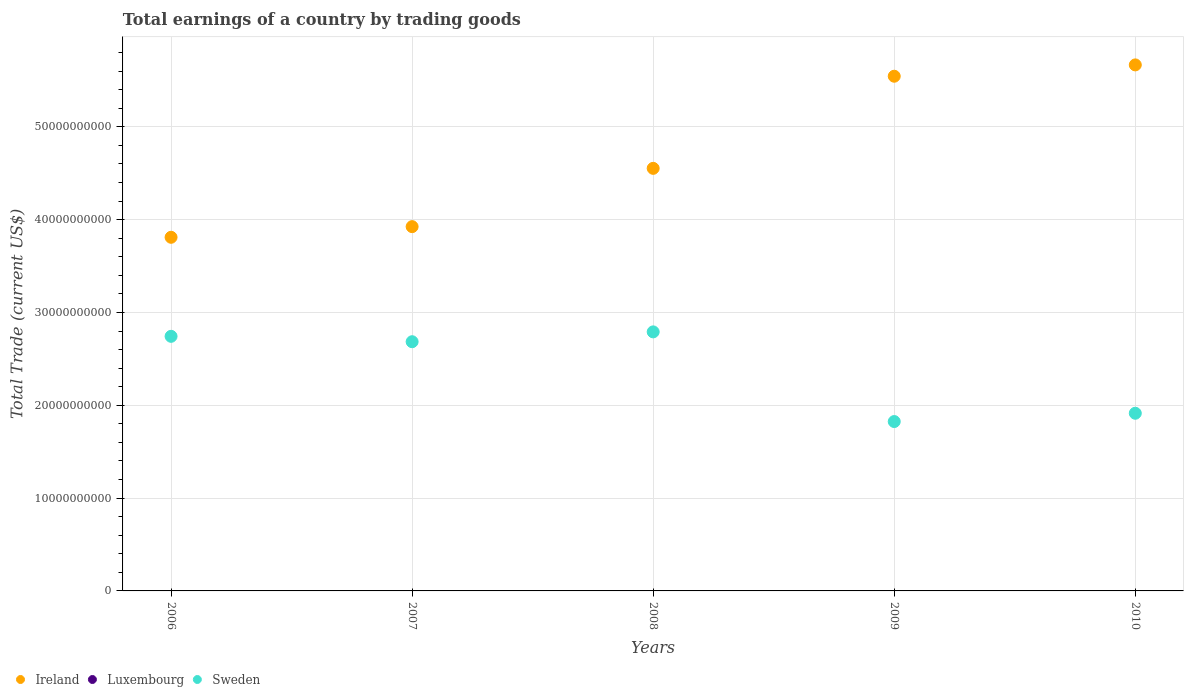What is the total earnings in Sweden in 2006?
Keep it short and to the point. 2.74e+1. Across all years, what is the maximum total earnings in Sweden?
Offer a terse response. 2.79e+1. Across all years, what is the minimum total earnings in Sweden?
Ensure brevity in your answer.  1.82e+1. In which year was the total earnings in Ireland maximum?
Your response must be concise. 2010. What is the total total earnings in Luxembourg in the graph?
Your answer should be compact. 0. What is the difference between the total earnings in Sweden in 2009 and that in 2010?
Provide a short and direct response. -8.94e+08. What is the difference between the total earnings in Luxembourg in 2008 and the total earnings in Ireland in 2010?
Give a very brief answer. -5.67e+1. What is the average total earnings in Luxembourg per year?
Your response must be concise. 0. In the year 2010, what is the difference between the total earnings in Ireland and total earnings in Sweden?
Ensure brevity in your answer.  3.75e+1. What is the ratio of the total earnings in Ireland in 2006 to that in 2010?
Make the answer very short. 0.67. Is the difference between the total earnings in Ireland in 2008 and 2009 greater than the difference between the total earnings in Sweden in 2008 and 2009?
Offer a very short reply. No. What is the difference between the highest and the second highest total earnings in Sweden?
Keep it short and to the point. 4.79e+08. What is the difference between the highest and the lowest total earnings in Ireland?
Provide a short and direct response. 1.86e+1. In how many years, is the total earnings in Luxembourg greater than the average total earnings in Luxembourg taken over all years?
Keep it short and to the point. 0. Is the sum of the total earnings in Ireland in 2006 and 2010 greater than the maximum total earnings in Luxembourg across all years?
Your response must be concise. Yes. Is it the case that in every year, the sum of the total earnings in Ireland and total earnings in Luxembourg  is greater than the total earnings in Sweden?
Provide a succinct answer. Yes. Does the total earnings in Luxembourg monotonically increase over the years?
Provide a short and direct response. No. Is the total earnings in Sweden strictly greater than the total earnings in Luxembourg over the years?
Offer a terse response. Yes. How many years are there in the graph?
Offer a terse response. 5. What is the difference between two consecutive major ticks on the Y-axis?
Keep it short and to the point. 1.00e+1. Are the values on the major ticks of Y-axis written in scientific E-notation?
Keep it short and to the point. No. Does the graph contain any zero values?
Keep it short and to the point. Yes. How many legend labels are there?
Provide a succinct answer. 3. How are the legend labels stacked?
Provide a short and direct response. Horizontal. What is the title of the graph?
Keep it short and to the point. Total earnings of a country by trading goods. Does "United Arab Emirates" appear as one of the legend labels in the graph?
Your answer should be very brief. No. What is the label or title of the Y-axis?
Make the answer very short. Total Trade (current US$). What is the Total Trade (current US$) of Ireland in 2006?
Your response must be concise. 3.81e+1. What is the Total Trade (current US$) of Sweden in 2006?
Your answer should be compact. 2.74e+1. What is the Total Trade (current US$) of Ireland in 2007?
Your response must be concise. 3.92e+1. What is the Total Trade (current US$) in Sweden in 2007?
Provide a short and direct response. 2.68e+1. What is the Total Trade (current US$) in Ireland in 2008?
Ensure brevity in your answer.  4.55e+1. What is the Total Trade (current US$) of Luxembourg in 2008?
Your answer should be very brief. 0. What is the Total Trade (current US$) in Sweden in 2008?
Your response must be concise. 2.79e+1. What is the Total Trade (current US$) in Ireland in 2009?
Offer a very short reply. 5.54e+1. What is the Total Trade (current US$) of Sweden in 2009?
Offer a very short reply. 1.82e+1. What is the Total Trade (current US$) of Ireland in 2010?
Provide a succinct answer. 5.67e+1. What is the Total Trade (current US$) of Sweden in 2010?
Provide a short and direct response. 1.91e+1. Across all years, what is the maximum Total Trade (current US$) in Ireland?
Give a very brief answer. 5.67e+1. Across all years, what is the maximum Total Trade (current US$) in Sweden?
Provide a succinct answer. 2.79e+1. Across all years, what is the minimum Total Trade (current US$) in Ireland?
Provide a short and direct response. 3.81e+1. Across all years, what is the minimum Total Trade (current US$) in Sweden?
Your answer should be very brief. 1.82e+1. What is the total Total Trade (current US$) in Ireland in the graph?
Make the answer very short. 2.35e+11. What is the total Total Trade (current US$) in Luxembourg in the graph?
Provide a short and direct response. 0. What is the total Total Trade (current US$) of Sweden in the graph?
Ensure brevity in your answer.  1.20e+11. What is the difference between the Total Trade (current US$) in Ireland in 2006 and that in 2007?
Give a very brief answer. -1.15e+09. What is the difference between the Total Trade (current US$) of Sweden in 2006 and that in 2007?
Keep it short and to the point. 5.80e+08. What is the difference between the Total Trade (current US$) in Ireland in 2006 and that in 2008?
Provide a short and direct response. -7.43e+09. What is the difference between the Total Trade (current US$) in Sweden in 2006 and that in 2008?
Provide a short and direct response. -4.79e+08. What is the difference between the Total Trade (current US$) of Ireland in 2006 and that in 2009?
Provide a succinct answer. -1.74e+1. What is the difference between the Total Trade (current US$) in Sweden in 2006 and that in 2009?
Give a very brief answer. 9.18e+09. What is the difference between the Total Trade (current US$) in Ireland in 2006 and that in 2010?
Provide a succinct answer. -1.86e+1. What is the difference between the Total Trade (current US$) of Sweden in 2006 and that in 2010?
Your response must be concise. 8.29e+09. What is the difference between the Total Trade (current US$) in Ireland in 2007 and that in 2008?
Provide a short and direct response. -6.28e+09. What is the difference between the Total Trade (current US$) of Sweden in 2007 and that in 2008?
Keep it short and to the point. -1.06e+09. What is the difference between the Total Trade (current US$) of Ireland in 2007 and that in 2009?
Your answer should be very brief. -1.62e+1. What is the difference between the Total Trade (current US$) in Sweden in 2007 and that in 2009?
Your answer should be very brief. 8.60e+09. What is the difference between the Total Trade (current US$) of Ireland in 2007 and that in 2010?
Your answer should be very brief. -1.74e+1. What is the difference between the Total Trade (current US$) in Sweden in 2007 and that in 2010?
Keep it short and to the point. 7.71e+09. What is the difference between the Total Trade (current US$) in Ireland in 2008 and that in 2009?
Your response must be concise. -9.92e+09. What is the difference between the Total Trade (current US$) in Sweden in 2008 and that in 2009?
Make the answer very short. 9.66e+09. What is the difference between the Total Trade (current US$) in Ireland in 2008 and that in 2010?
Ensure brevity in your answer.  -1.11e+1. What is the difference between the Total Trade (current US$) of Sweden in 2008 and that in 2010?
Make the answer very short. 8.77e+09. What is the difference between the Total Trade (current US$) of Ireland in 2009 and that in 2010?
Your answer should be very brief. -1.22e+09. What is the difference between the Total Trade (current US$) of Sweden in 2009 and that in 2010?
Your answer should be very brief. -8.94e+08. What is the difference between the Total Trade (current US$) in Ireland in 2006 and the Total Trade (current US$) in Sweden in 2007?
Keep it short and to the point. 1.13e+1. What is the difference between the Total Trade (current US$) of Ireland in 2006 and the Total Trade (current US$) of Sweden in 2008?
Ensure brevity in your answer.  1.02e+1. What is the difference between the Total Trade (current US$) of Ireland in 2006 and the Total Trade (current US$) of Sweden in 2009?
Ensure brevity in your answer.  1.99e+1. What is the difference between the Total Trade (current US$) of Ireland in 2006 and the Total Trade (current US$) of Sweden in 2010?
Ensure brevity in your answer.  1.90e+1. What is the difference between the Total Trade (current US$) in Ireland in 2007 and the Total Trade (current US$) in Sweden in 2008?
Your answer should be compact. 1.13e+1. What is the difference between the Total Trade (current US$) of Ireland in 2007 and the Total Trade (current US$) of Sweden in 2009?
Give a very brief answer. 2.10e+1. What is the difference between the Total Trade (current US$) in Ireland in 2007 and the Total Trade (current US$) in Sweden in 2010?
Ensure brevity in your answer.  2.01e+1. What is the difference between the Total Trade (current US$) in Ireland in 2008 and the Total Trade (current US$) in Sweden in 2009?
Your answer should be compact. 2.73e+1. What is the difference between the Total Trade (current US$) of Ireland in 2008 and the Total Trade (current US$) of Sweden in 2010?
Offer a very short reply. 2.64e+1. What is the difference between the Total Trade (current US$) of Ireland in 2009 and the Total Trade (current US$) of Sweden in 2010?
Ensure brevity in your answer.  3.63e+1. What is the average Total Trade (current US$) of Ireland per year?
Your response must be concise. 4.70e+1. What is the average Total Trade (current US$) in Sweden per year?
Provide a succinct answer. 2.39e+1. In the year 2006, what is the difference between the Total Trade (current US$) in Ireland and Total Trade (current US$) in Sweden?
Ensure brevity in your answer.  1.07e+1. In the year 2007, what is the difference between the Total Trade (current US$) in Ireland and Total Trade (current US$) in Sweden?
Make the answer very short. 1.24e+1. In the year 2008, what is the difference between the Total Trade (current US$) of Ireland and Total Trade (current US$) of Sweden?
Provide a short and direct response. 1.76e+1. In the year 2009, what is the difference between the Total Trade (current US$) of Ireland and Total Trade (current US$) of Sweden?
Your answer should be compact. 3.72e+1. In the year 2010, what is the difference between the Total Trade (current US$) in Ireland and Total Trade (current US$) in Sweden?
Offer a very short reply. 3.75e+1. What is the ratio of the Total Trade (current US$) in Ireland in 2006 to that in 2007?
Provide a short and direct response. 0.97. What is the ratio of the Total Trade (current US$) of Sweden in 2006 to that in 2007?
Make the answer very short. 1.02. What is the ratio of the Total Trade (current US$) of Ireland in 2006 to that in 2008?
Give a very brief answer. 0.84. What is the ratio of the Total Trade (current US$) of Sweden in 2006 to that in 2008?
Provide a succinct answer. 0.98. What is the ratio of the Total Trade (current US$) of Ireland in 2006 to that in 2009?
Your response must be concise. 0.69. What is the ratio of the Total Trade (current US$) in Sweden in 2006 to that in 2009?
Provide a short and direct response. 1.5. What is the ratio of the Total Trade (current US$) of Ireland in 2006 to that in 2010?
Your answer should be compact. 0.67. What is the ratio of the Total Trade (current US$) in Sweden in 2006 to that in 2010?
Offer a terse response. 1.43. What is the ratio of the Total Trade (current US$) of Ireland in 2007 to that in 2008?
Offer a very short reply. 0.86. What is the ratio of the Total Trade (current US$) of Sweden in 2007 to that in 2008?
Provide a succinct answer. 0.96. What is the ratio of the Total Trade (current US$) in Ireland in 2007 to that in 2009?
Your answer should be compact. 0.71. What is the ratio of the Total Trade (current US$) in Sweden in 2007 to that in 2009?
Your answer should be very brief. 1.47. What is the ratio of the Total Trade (current US$) of Ireland in 2007 to that in 2010?
Offer a terse response. 0.69. What is the ratio of the Total Trade (current US$) of Sweden in 2007 to that in 2010?
Provide a succinct answer. 1.4. What is the ratio of the Total Trade (current US$) of Ireland in 2008 to that in 2009?
Your answer should be very brief. 0.82. What is the ratio of the Total Trade (current US$) in Sweden in 2008 to that in 2009?
Keep it short and to the point. 1.53. What is the ratio of the Total Trade (current US$) of Ireland in 2008 to that in 2010?
Offer a terse response. 0.8. What is the ratio of the Total Trade (current US$) of Sweden in 2008 to that in 2010?
Keep it short and to the point. 1.46. What is the ratio of the Total Trade (current US$) in Ireland in 2009 to that in 2010?
Provide a short and direct response. 0.98. What is the ratio of the Total Trade (current US$) in Sweden in 2009 to that in 2010?
Keep it short and to the point. 0.95. What is the difference between the highest and the second highest Total Trade (current US$) in Ireland?
Your response must be concise. 1.22e+09. What is the difference between the highest and the second highest Total Trade (current US$) of Sweden?
Your answer should be compact. 4.79e+08. What is the difference between the highest and the lowest Total Trade (current US$) of Ireland?
Your answer should be compact. 1.86e+1. What is the difference between the highest and the lowest Total Trade (current US$) in Sweden?
Your answer should be very brief. 9.66e+09. 